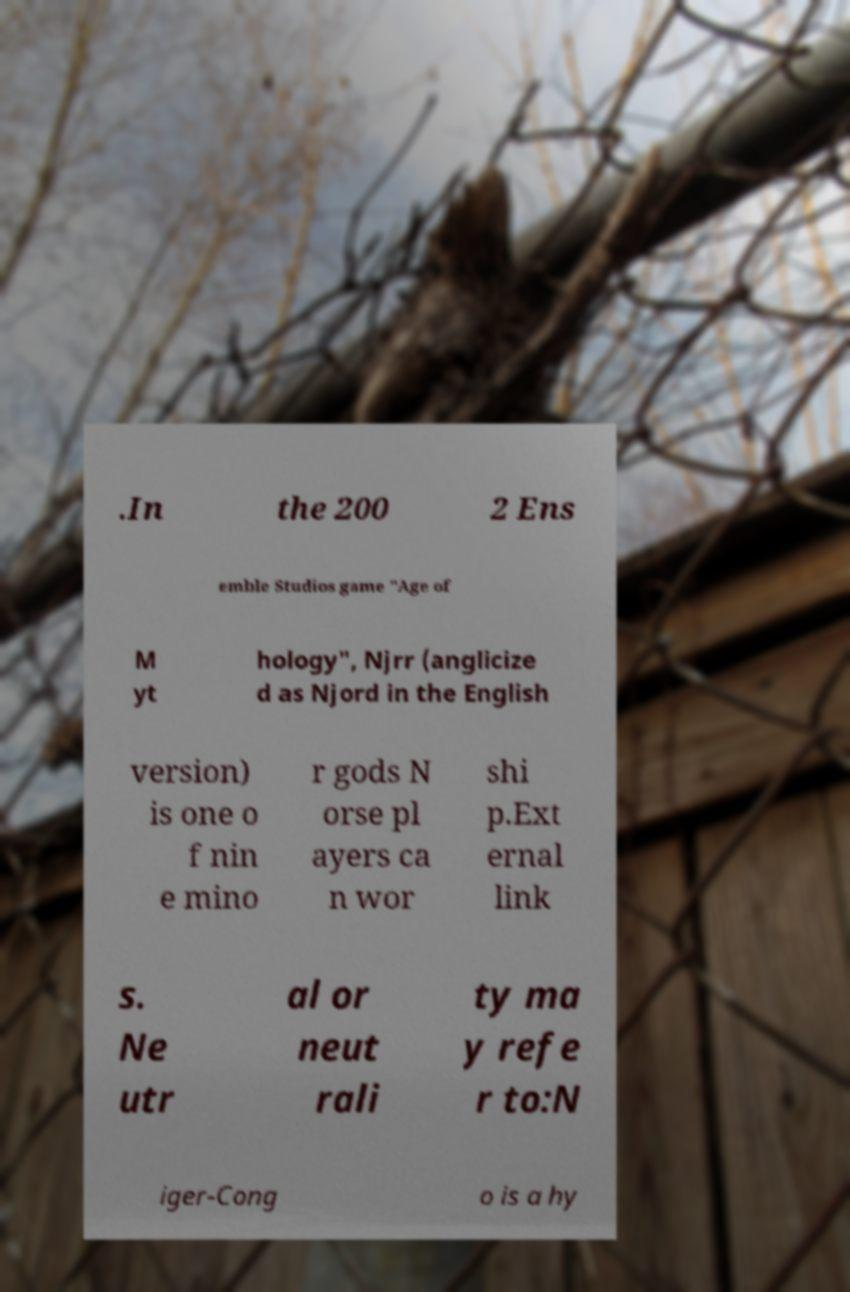What messages or text are displayed in this image? I need them in a readable, typed format. .In the 200 2 Ens emble Studios game "Age of M yt hology", Njrr (anglicize d as Njord in the English version) is one o f nin e mino r gods N orse pl ayers ca n wor shi p.Ext ernal link s. Ne utr al or neut rali ty ma y refe r to:N iger-Cong o is a hy 